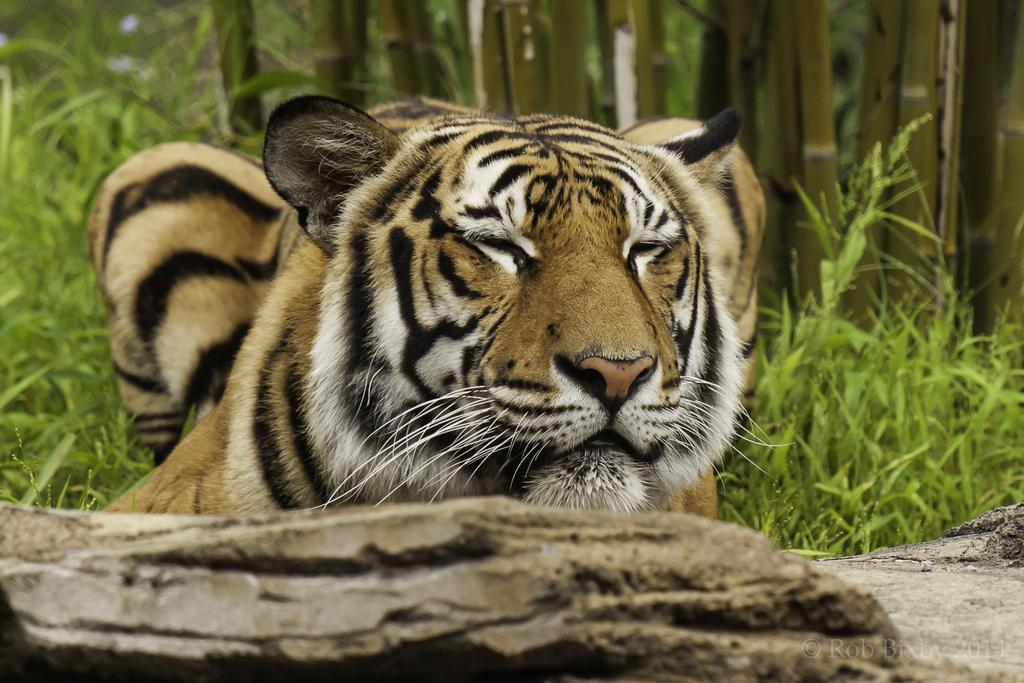What animal is present in the image? There is a tiger in the image. What type of vegetation can be seen in the background of the image? There are bamboo sticks and grass in the background of the image. Can you describe the terrain at the bottom of the image? There appears to be a rock at the bottom of the image. What type of boat can be seen in the image? There is no boat present in the image. Is there any sleet visible in the image? There is no sleet present in the image; the weather cannot be determined from the image. 